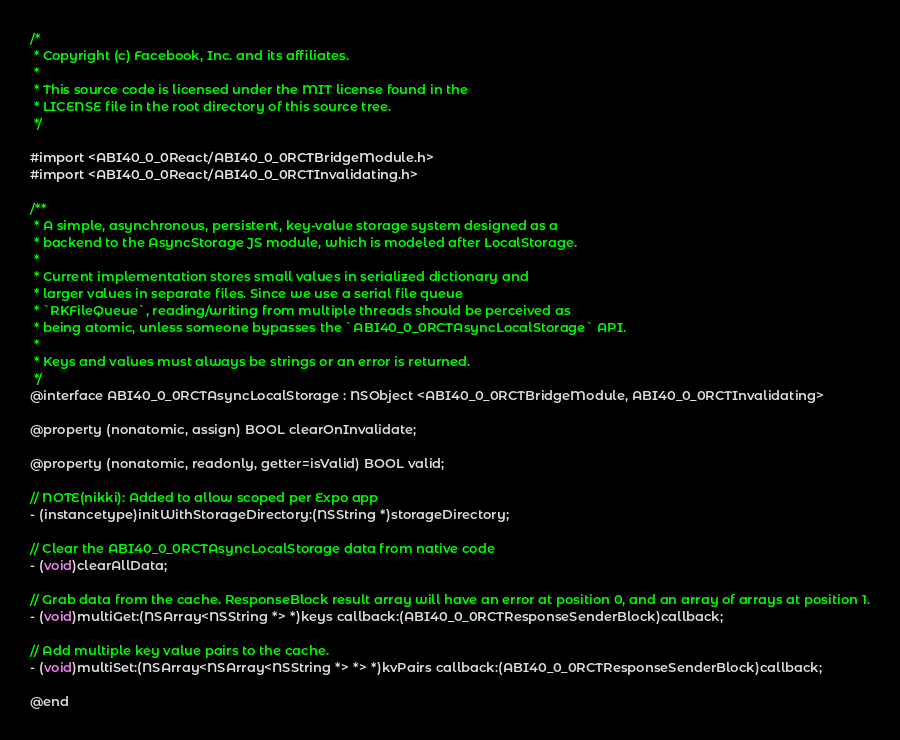Convert code to text. <code><loc_0><loc_0><loc_500><loc_500><_C_>/*
 * Copyright (c) Facebook, Inc. and its affiliates.
 *
 * This source code is licensed under the MIT license found in the
 * LICENSE file in the root directory of this source tree.
 */

#import <ABI40_0_0React/ABI40_0_0RCTBridgeModule.h>
#import <ABI40_0_0React/ABI40_0_0RCTInvalidating.h>

/**
 * A simple, asynchronous, persistent, key-value storage system designed as a
 * backend to the AsyncStorage JS module, which is modeled after LocalStorage.
 *
 * Current implementation stores small values in serialized dictionary and
 * larger values in separate files. Since we use a serial file queue
 * `RKFileQueue`, reading/writing from multiple threads should be perceived as
 * being atomic, unless someone bypasses the `ABI40_0_0RCTAsyncLocalStorage` API.
 *
 * Keys and values must always be strings or an error is returned.
 */
@interface ABI40_0_0RCTAsyncLocalStorage : NSObject <ABI40_0_0RCTBridgeModule, ABI40_0_0RCTInvalidating>

@property (nonatomic, assign) BOOL clearOnInvalidate;

@property (nonatomic, readonly, getter=isValid) BOOL valid;

// NOTE(nikki): Added to allow scoped per Expo app
- (instancetype)initWithStorageDirectory:(NSString *)storageDirectory;

// Clear the ABI40_0_0RCTAsyncLocalStorage data from native code
- (void)clearAllData;

// Grab data from the cache. ResponseBlock result array will have an error at position 0, and an array of arrays at position 1.
- (void)multiGet:(NSArray<NSString *> *)keys callback:(ABI40_0_0RCTResponseSenderBlock)callback;

// Add multiple key value pairs to the cache.
- (void)multiSet:(NSArray<NSArray<NSString *> *> *)kvPairs callback:(ABI40_0_0RCTResponseSenderBlock)callback;

@end
</code> 